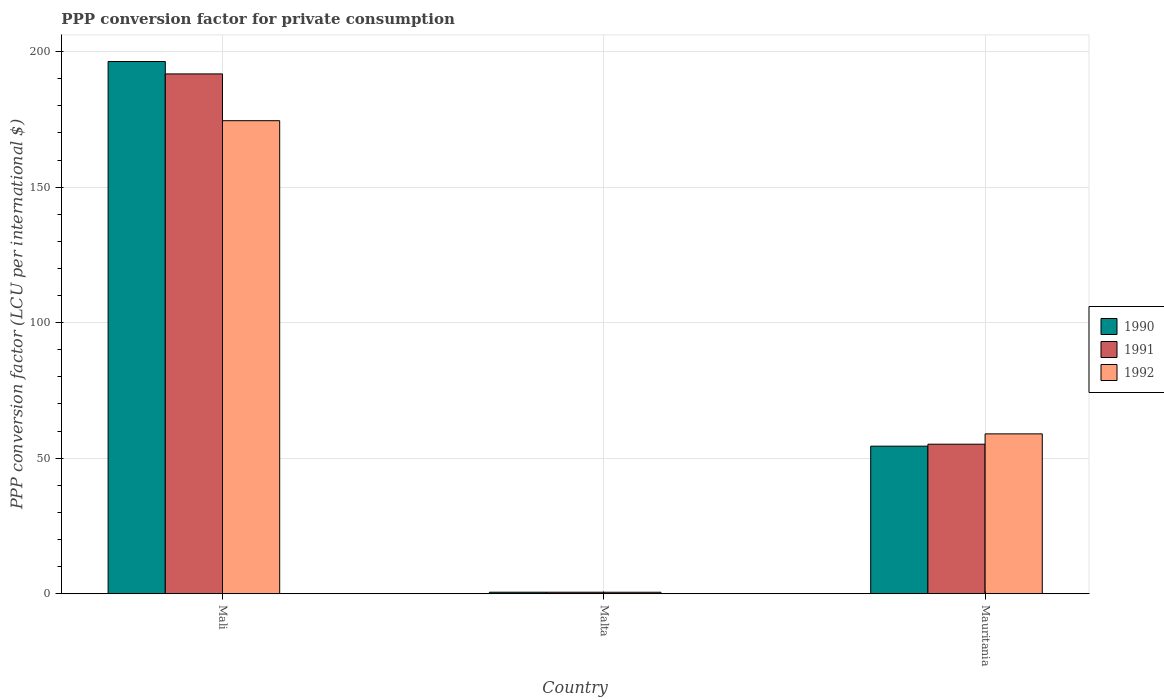How many different coloured bars are there?
Provide a succinct answer. 3. How many groups of bars are there?
Provide a short and direct response. 3. What is the label of the 1st group of bars from the left?
Your answer should be compact. Mali. What is the PPP conversion factor for private consumption in 1992 in Mali?
Your answer should be compact. 174.51. Across all countries, what is the maximum PPP conversion factor for private consumption in 1992?
Offer a very short reply. 174.51. Across all countries, what is the minimum PPP conversion factor for private consumption in 1991?
Your response must be concise. 0.56. In which country was the PPP conversion factor for private consumption in 1992 maximum?
Your answer should be compact. Mali. In which country was the PPP conversion factor for private consumption in 1991 minimum?
Provide a succinct answer. Malta. What is the total PPP conversion factor for private consumption in 1992 in the graph?
Offer a terse response. 234.03. What is the difference between the PPP conversion factor for private consumption in 1990 in Mali and that in Malta?
Give a very brief answer. 195.78. What is the difference between the PPP conversion factor for private consumption in 1990 in Mauritania and the PPP conversion factor for private consumption in 1992 in Mali?
Ensure brevity in your answer.  -120.07. What is the average PPP conversion factor for private consumption in 1991 per country?
Provide a succinct answer. 82.5. What is the difference between the PPP conversion factor for private consumption of/in 1992 and PPP conversion factor for private consumption of/in 1991 in Mali?
Your response must be concise. -17.26. What is the ratio of the PPP conversion factor for private consumption in 1990 in Mali to that in Mauritania?
Provide a succinct answer. 3.61. Is the PPP conversion factor for private consumption in 1991 in Malta less than that in Mauritania?
Your answer should be very brief. Yes. What is the difference between the highest and the second highest PPP conversion factor for private consumption in 1992?
Make the answer very short. -58.43. What is the difference between the highest and the lowest PPP conversion factor for private consumption in 1990?
Keep it short and to the point. 195.78. In how many countries, is the PPP conversion factor for private consumption in 1991 greater than the average PPP conversion factor for private consumption in 1991 taken over all countries?
Offer a terse response. 1. What does the 2nd bar from the right in Mali represents?
Your answer should be very brief. 1991. Is it the case that in every country, the sum of the PPP conversion factor for private consumption in 1992 and PPP conversion factor for private consumption in 1990 is greater than the PPP conversion factor for private consumption in 1991?
Keep it short and to the point. Yes. How many bars are there?
Keep it short and to the point. 9. What is the title of the graph?
Your response must be concise. PPP conversion factor for private consumption. What is the label or title of the Y-axis?
Provide a succinct answer. PPP conversion factor (LCU per international $). What is the PPP conversion factor (LCU per international $) of 1990 in Mali?
Your response must be concise. 196.35. What is the PPP conversion factor (LCU per international $) in 1991 in Mali?
Provide a short and direct response. 191.76. What is the PPP conversion factor (LCU per international $) of 1992 in Mali?
Provide a succinct answer. 174.51. What is the PPP conversion factor (LCU per international $) of 1990 in Malta?
Offer a very short reply. 0.57. What is the PPP conversion factor (LCU per international $) of 1991 in Malta?
Make the answer very short. 0.56. What is the PPP conversion factor (LCU per international $) in 1992 in Malta?
Your answer should be very brief. 0.55. What is the PPP conversion factor (LCU per international $) of 1990 in Mauritania?
Give a very brief answer. 54.44. What is the PPP conversion factor (LCU per international $) in 1991 in Mauritania?
Give a very brief answer. 55.17. What is the PPP conversion factor (LCU per international $) of 1992 in Mauritania?
Provide a short and direct response. 58.98. Across all countries, what is the maximum PPP conversion factor (LCU per international $) of 1990?
Provide a short and direct response. 196.35. Across all countries, what is the maximum PPP conversion factor (LCU per international $) in 1991?
Offer a terse response. 191.76. Across all countries, what is the maximum PPP conversion factor (LCU per international $) in 1992?
Your answer should be very brief. 174.51. Across all countries, what is the minimum PPP conversion factor (LCU per international $) of 1990?
Give a very brief answer. 0.57. Across all countries, what is the minimum PPP conversion factor (LCU per international $) in 1991?
Give a very brief answer. 0.56. Across all countries, what is the minimum PPP conversion factor (LCU per international $) of 1992?
Offer a very short reply. 0.55. What is the total PPP conversion factor (LCU per international $) of 1990 in the graph?
Your answer should be very brief. 251.35. What is the total PPP conversion factor (LCU per international $) in 1991 in the graph?
Offer a very short reply. 247.49. What is the total PPP conversion factor (LCU per international $) in 1992 in the graph?
Ensure brevity in your answer.  234.03. What is the difference between the PPP conversion factor (LCU per international $) in 1990 in Mali and that in Malta?
Give a very brief answer. 195.78. What is the difference between the PPP conversion factor (LCU per international $) in 1991 in Mali and that in Malta?
Provide a short and direct response. 191.2. What is the difference between the PPP conversion factor (LCU per international $) in 1992 in Mali and that in Malta?
Your response must be concise. 173.95. What is the difference between the PPP conversion factor (LCU per international $) of 1990 in Mali and that in Mauritania?
Offer a terse response. 141.91. What is the difference between the PPP conversion factor (LCU per international $) of 1991 in Mali and that in Mauritania?
Make the answer very short. 136.59. What is the difference between the PPP conversion factor (LCU per international $) in 1992 in Mali and that in Mauritania?
Offer a terse response. 115.53. What is the difference between the PPP conversion factor (LCU per international $) in 1990 in Malta and that in Mauritania?
Offer a terse response. -53.87. What is the difference between the PPP conversion factor (LCU per international $) in 1991 in Malta and that in Mauritania?
Ensure brevity in your answer.  -54.61. What is the difference between the PPP conversion factor (LCU per international $) of 1992 in Malta and that in Mauritania?
Make the answer very short. -58.43. What is the difference between the PPP conversion factor (LCU per international $) of 1990 in Mali and the PPP conversion factor (LCU per international $) of 1991 in Malta?
Keep it short and to the point. 195.79. What is the difference between the PPP conversion factor (LCU per international $) of 1990 in Mali and the PPP conversion factor (LCU per international $) of 1992 in Malta?
Provide a succinct answer. 195.8. What is the difference between the PPP conversion factor (LCU per international $) in 1991 in Mali and the PPP conversion factor (LCU per international $) in 1992 in Malta?
Provide a succinct answer. 191.21. What is the difference between the PPP conversion factor (LCU per international $) in 1990 in Mali and the PPP conversion factor (LCU per international $) in 1991 in Mauritania?
Offer a terse response. 141.18. What is the difference between the PPP conversion factor (LCU per international $) in 1990 in Mali and the PPP conversion factor (LCU per international $) in 1992 in Mauritania?
Keep it short and to the point. 137.37. What is the difference between the PPP conversion factor (LCU per international $) in 1991 in Mali and the PPP conversion factor (LCU per international $) in 1992 in Mauritania?
Offer a very short reply. 132.78. What is the difference between the PPP conversion factor (LCU per international $) of 1990 in Malta and the PPP conversion factor (LCU per international $) of 1991 in Mauritania?
Give a very brief answer. -54.6. What is the difference between the PPP conversion factor (LCU per international $) of 1990 in Malta and the PPP conversion factor (LCU per international $) of 1992 in Mauritania?
Your answer should be very brief. -58.41. What is the difference between the PPP conversion factor (LCU per international $) in 1991 in Malta and the PPP conversion factor (LCU per international $) in 1992 in Mauritania?
Make the answer very short. -58.42. What is the average PPP conversion factor (LCU per international $) of 1990 per country?
Ensure brevity in your answer.  83.78. What is the average PPP conversion factor (LCU per international $) of 1991 per country?
Your response must be concise. 82.5. What is the average PPP conversion factor (LCU per international $) in 1992 per country?
Keep it short and to the point. 78.01. What is the difference between the PPP conversion factor (LCU per international $) in 1990 and PPP conversion factor (LCU per international $) in 1991 in Mali?
Provide a short and direct response. 4.59. What is the difference between the PPP conversion factor (LCU per international $) in 1990 and PPP conversion factor (LCU per international $) in 1992 in Mali?
Offer a terse response. 21.84. What is the difference between the PPP conversion factor (LCU per international $) of 1991 and PPP conversion factor (LCU per international $) of 1992 in Mali?
Offer a terse response. 17.26. What is the difference between the PPP conversion factor (LCU per international $) of 1990 and PPP conversion factor (LCU per international $) of 1991 in Malta?
Keep it short and to the point. 0.01. What is the difference between the PPP conversion factor (LCU per international $) in 1990 and PPP conversion factor (LCU per international $) in 1992 in Malta?
Offer a terse response. 0.02. What is the difference between the PPP conversion factor (LCU per international $) in 1991 and PPP conversion factor (LCU per international $) in 1992 in Malta?
Your answer should be compact. 0.01. What is the difference between the PPP conversion factor (LCU per international $) in 1990 and PPP conversion factor (LCU per international $) in 1991 in Mauritania?
Provide a short and direct response. -0.73. What is the difference between the PPP conversion factor (LCU per international $) of 1990 and PPP conversion factor (LCU per international $) of 1992 in Mauritania?
Offer a very short reply. -4.54. What is the difference between the PPP conversion factor (LCU per international $) in 1991 and PPP conversion factor (LCU per international $) in 1992 in Mauritania?
Provide a short and direct response. -3.81. What is the ratio of the PPP conversion factor (LCU per international $) of 1990 in Mali to that in Malta?
Ensure brevity in your answer.  346.22. What is the ratio of the PPP conversion factor (LCU per international $) of 1991 in Mali to that in Malta?
Your answer should be compact. 343.72. What is the ratio of the PPP conversion factor (LCU per international $) of 1992 in Mali to that in Malta?
Your response must be concise. 317.08. What is the ratio of the PPP conversion factor (LCU per international $) of 1990 in Mali to that in Mauritania?
Ensure brevity in your answer.  3.61. What is the ratio of the PPP conversion factor (LCU per international $) in 1991 in Mali to that in Mauritania?
Ensure brevity in your answer.  3.48. What is the ratio of the PPP conversion factor (LCU per international $) of 1992 in Mali to that in Mauritania?
Your response must be concise. 2.96. What is the ratio of the PPP conversion factor (LCU per international $) of 1990 in Malta to that in Mauritania?
Make the answer very short. 0.01. What is the ratio of the PPP conversion factor (LCU per international $) of 1991 in Malta to that in Mauritania?
Your answer should be very brief. 0.01. What is the ratio of the PPP conversion factor (LCU per international $) of 1992 in Malta to that in Mauritania?
Provide a short and direct response. 0.01. What is the difference between the highest and the second highest PPP conversion factor (LCU per international $) in 1990?
Ensure brevity in your answer.  141.91. What is the difference between the highest and the second highest PPP conversion factor (LCU per international $) in 1991?
Make the answer very short. 136.59. What is the difference between the highest and the second highest PPP conversion factor (LCU per international $) of 1992?
Provide a short and direct response. 115.53. What is the difference between the highest and the lowest PPP conversion factor (LCU per international $) in 1990?
Your response must be concise. 195.78. What is the difference between the highest and the lowest PPP conversion factor (LCU per international $) of 1991?
Your response must be concise. 191.2. What is the difference between the highest and the lowest PPP conversion factor (LCU per international $) of 1992?
Ensure brevity in your answer.  173.95. 